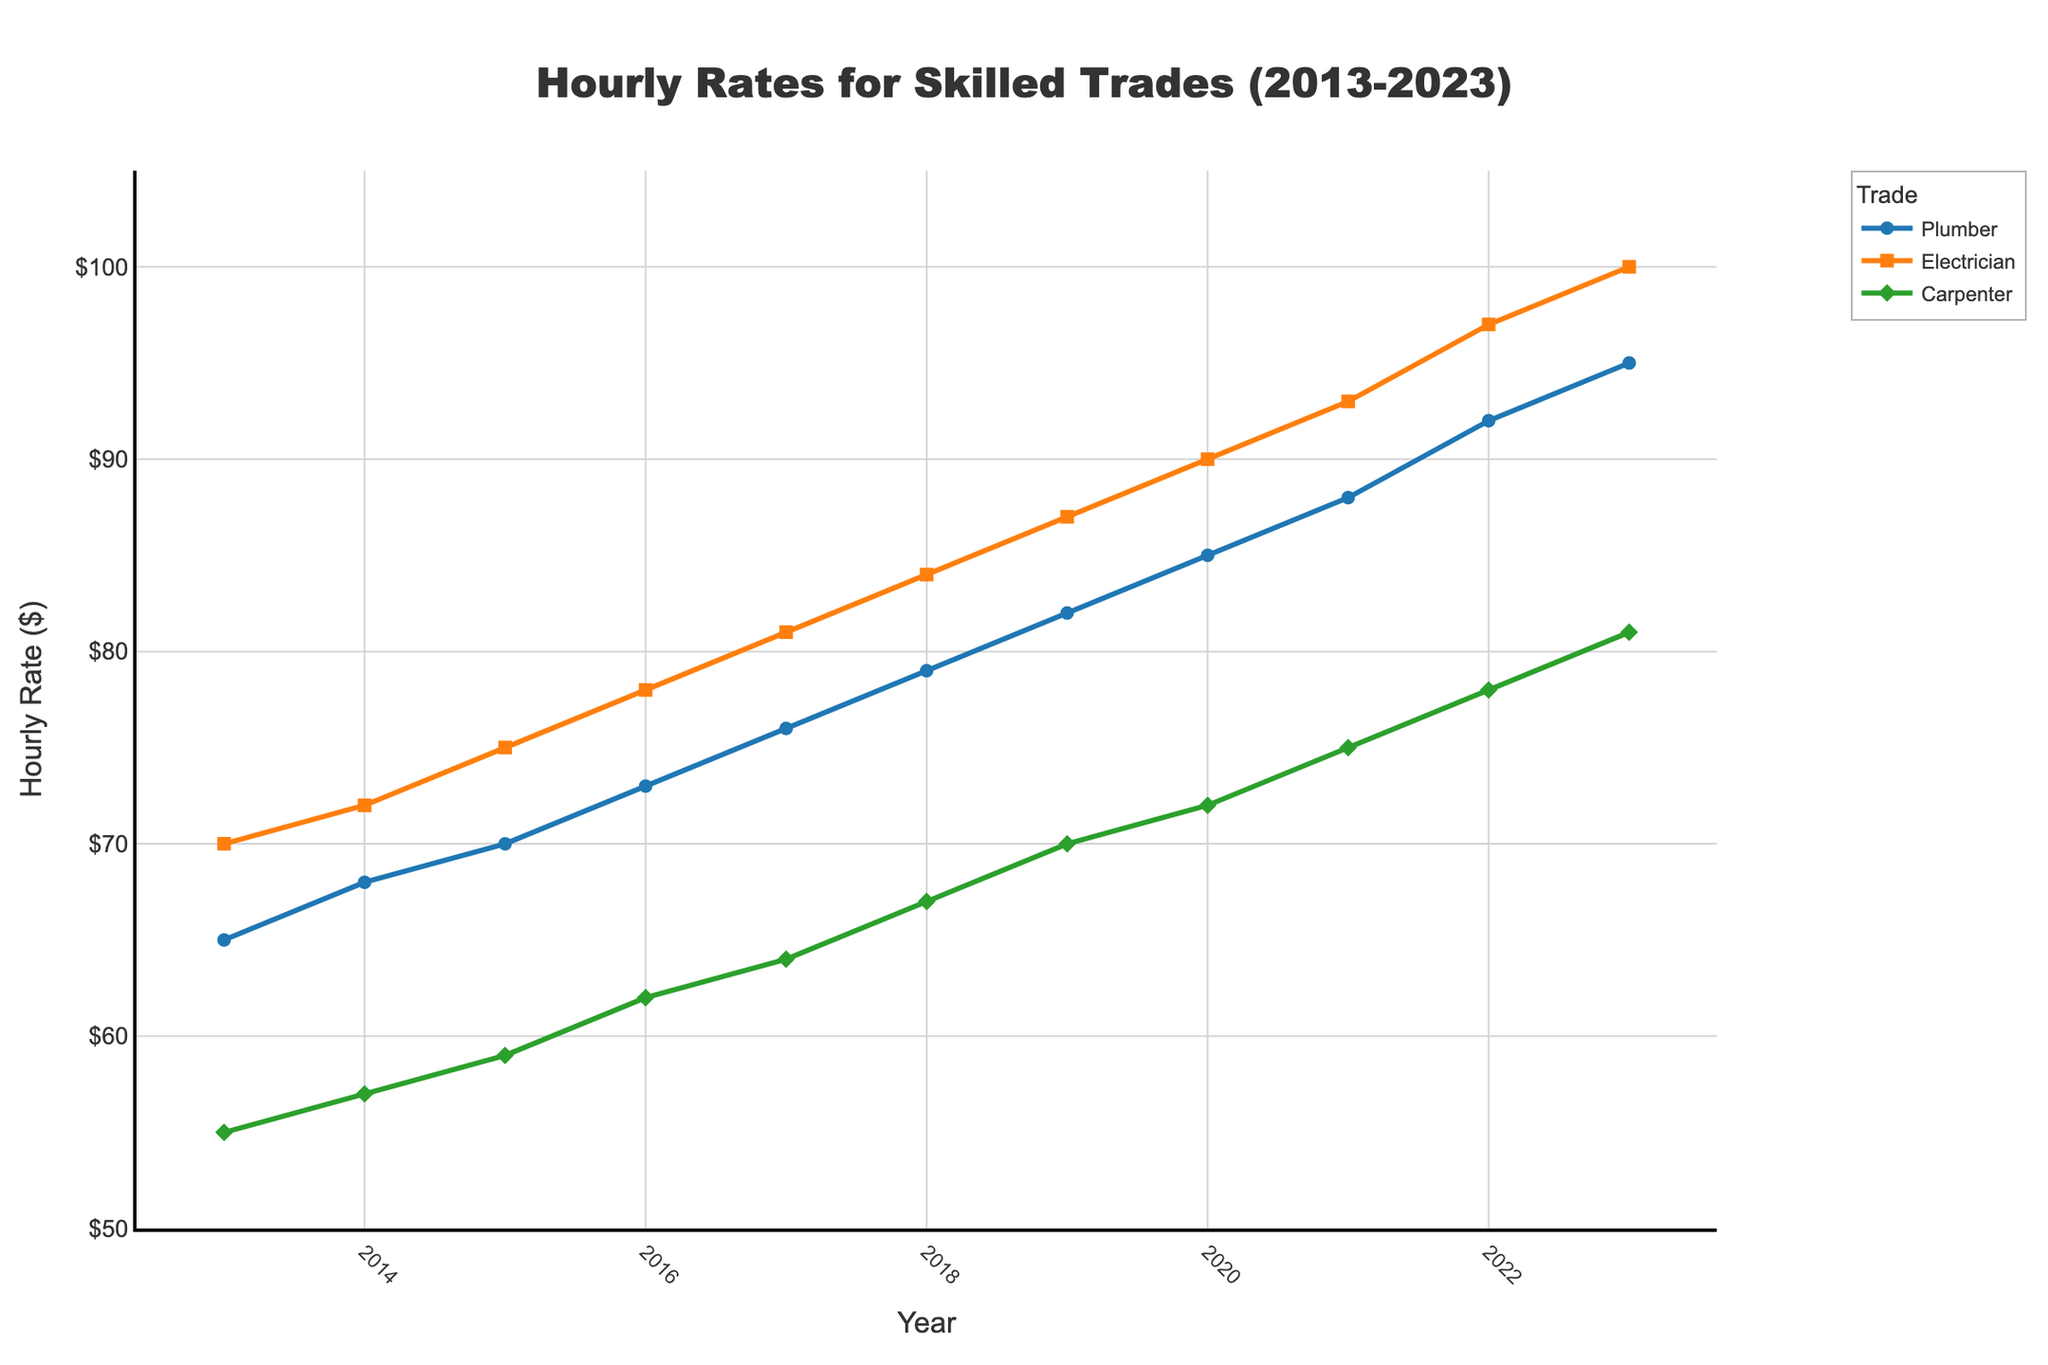What's the overall trend in the hourly rates for plumbers from 2013 to 2023? The figure shows that the hourly rates for plumbers have steadily increased over the decade, starting from $65 in 2013 and reaching $95 in 2023. The trend is a continuous upward slope.
Answer: Steadily increasing Which skilled trade had the highest hourly rate in 2023? In 2023, the figure shows that the hourly rate for electricians is the highest among the three trades, reaching $100.
Answer: Electrician By how much did the hourly rate for carpenters increase from 2013 to 2023? The hourly rate for carpenters started at $55 in 2013 and increased to $81 in 2023. The difference is calculated as $81 - $55.
Answer: $26 Between which years did the plumber's hourly rate see the largest incremental increase? By examining the figure, the largest single-year increase for plumbers occurred between 2021 and 2022, where the rate increased from $88 to $92, a difference of $4.
Answer: Between 2021 and 2022 Compare the hourly rates for electricians and plumbers in 2015. Which trade had a higher rate, and by how much? In 2015, the hourly rate for electricians was $75, while for plumbers it was $70. The difference is calculated as $75 - $70.
Answer: Electricians by $5 What is the average hourly rate for carpenters over the entire decade? To find the average, add the hourly rates of 55, 57, 59, 62, 64, 67, 70, 72, 75, 78, and 81, then divide by the total number of years (11): (55+57+59+62+64+67+70+72+75+78+81)/11. The sum is 740, and 740/11 ≈ 67.27.
Answer: Approximately $67.27 If the trend continues, what would you estimate the carpenter's hourly rate to be in 2024? The carpenter's hourly rate increased by about $3 per year over the past decade. Assuming this trend continues, the rate in 2024 could be estimated as $81 + $3.
Answer: $84 How has the gap in hourly rates between electricians and carpenters changed from 2013 to 2023? In 2013, the gap between electricians ($70) and carpenters ($55) was $15. In 2023, electricians ($100) and carpenters ($81) have a difference of $19. The gap has increased by $4 over the decade.
Answer: Increased by $4 Which year did all three trades share the closest hourly rate, and what were those rates? By examining the rates each year, 2014 shows the closest rates where plumber was $68, electrician was $72, and carpenter was $57. The rates are within the smallest range.
Answer: 2014: Plumber $68, Electrician $72, Carpenter $57 What color visually represents the carpenter's hourly rate in the plot? The carpenter's hourly rate is represented by a green line with diamond markers in the figure.
Answer: Green 